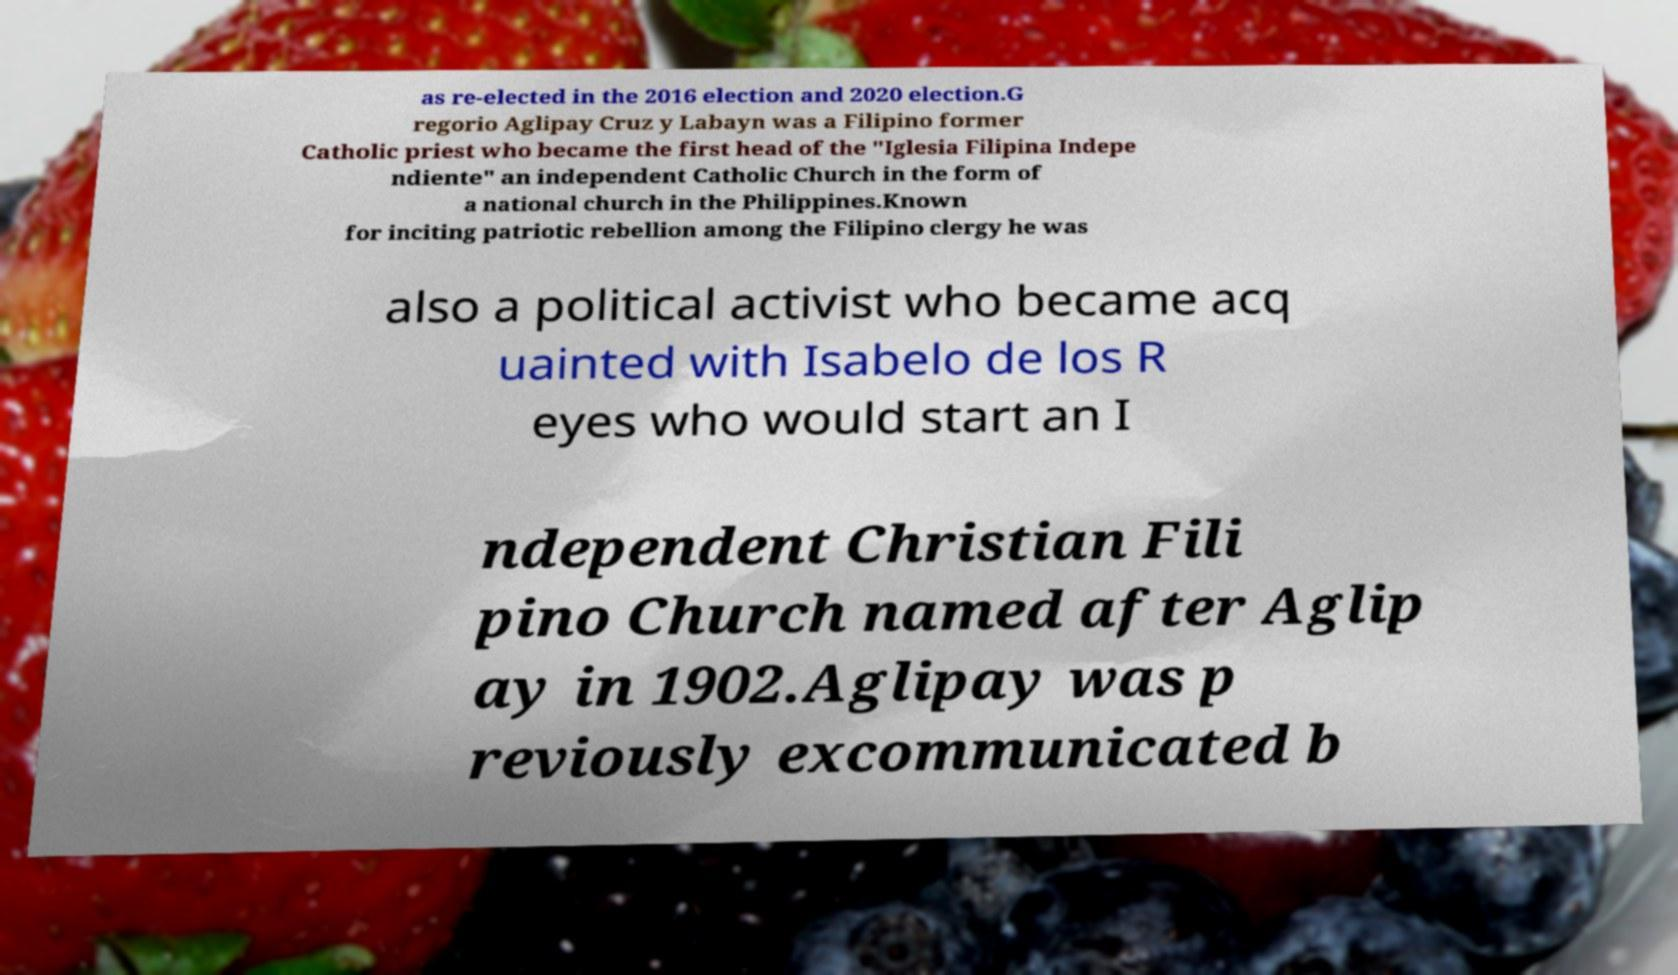There's text embedded in this image that I need extracted. Can you transcribe it verbatim? as re-elected in the 2016 election and 2020 election.G regorio Aglipay Cruz y Labayn was a Filipino former Catholic priest who became the first head of the "Iglesia Filipina Indepe ndiente" an independent Catholic Church in the form of a national church in the Philippines.Known for inciting patriotic rebellion among the Filipino clergy he was also a political activist who became acq uainted with Isabelo de los R eyes who would start an I ndependent Christian Fili pino Church named after Aglip ay in 1902.Aglipay was p reviously excommunicated b 